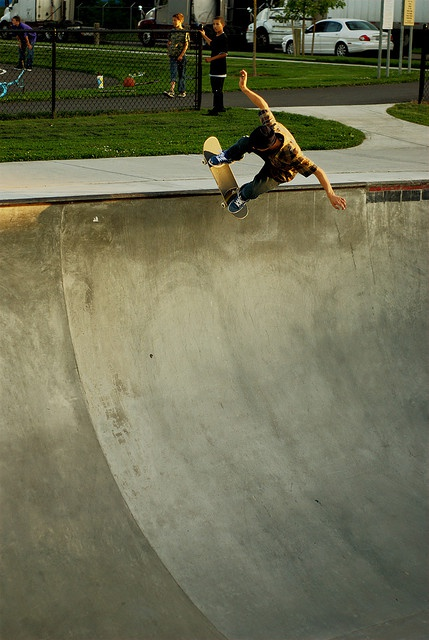Describe the objects in this image and their specific colors. I can see people in blue, black, maroon, olive, and brown tones, car in blue, darkgray, black, gray, and teal tones, car in blue, black, darkgray, gray, and darkgreen tones, truck in blue, black, gray, darkgreen, and darkgray tones, and truck in blue, black, darkgreen, and gray tones in this image. 